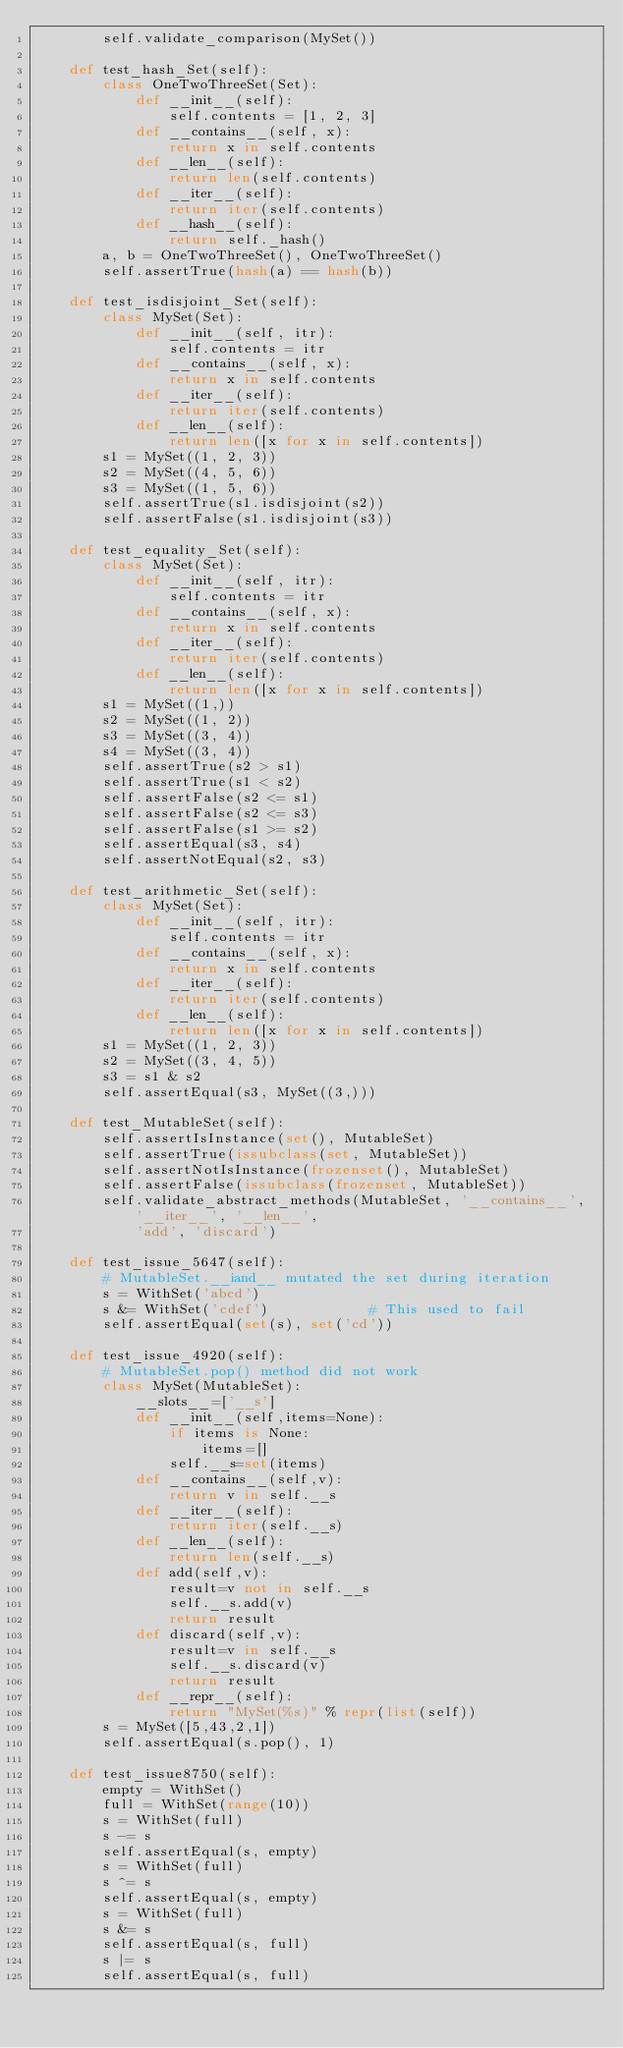<code> <loc_0><loc_0><loc_500><loc_500><_Python_>        self.validate_comparison(MySet())

    def test_hash_Set(self):
        class OneTwoThreeSet(Set):
            def __init__(self):
                self.contents = [1, 2, 3]
            def __contains__(self, x):
                return x in self.contents
            def __len__(self):
                return len(self.contents)
            def __iter__(self):
                return iter(self.contents)
            def __hash__(self):
                return self._hash()
        a, b = OneTwoThreeSet(), OneTwoThreeSet()
        self.assertTrue(hash(a) == hash(b))

    def test_isdisjoint_Set(self):
        class MySet(Set):
            def __init__(self, itr):
                self.contents = itr
            def __contains__(self, x):
                return x in self.contents
            def __iter__(self):
                return iter(self.contents)
            def __len__(self):
                return len([x for x in self.contents])
        s1 = MySet((1, 2, 3))
        s2 = MySet((4, 5, 6))
        s3 = MySet((1, 5, 6))
        self.assertTrue(s1.isdisjoint(s2))
        self.assertFalse(s1.isdisjoint(s3))

    def test_equality_Set(self):
        class MySet(Set):
            def __init__(self, itr):
                self.contents = itr
            def __contains__(self, x):
                return x in self.contents
            def __iter__(self):
                return iter(self.contents)
            def __len__(self):
                return len([x for x in self.contents])
        s1 = MySet((1,))
        s2 = MySet((1, 2))
        s3 = MySet((3, 4))
        s4 = MySet((3, 4))
        self.assertTrue(s2 > s1)
        self.assertTrue(s1 < s2)
        self.assertFalse(s2 <= s1)
        self.assertFalse(s2 <= s3)
        self.assertFalse(s1 >= s2)
        self.assertEqual(s3, s4)
        self.assertNotEqual(s2, s3)

    def test_arithmetic_Set(self):
        class MySet(Set):
            def __init__(self, itr):
                self.contents = itr
            def __contains__(self, x):
                return x in self.contents
            def __iter__(self):
                return iter(self.contents)
            def __len__(self):
                return len([x for x in self.contents])
        s1 = MySet((1, 2, 3))
        s2 = MySet((3, 4, 5))
        s3 = s1 & s2
        self.assertEqual(s3, MySet((3,)))

    def test_MutableSet(self):
        self.assertIsInstance(set(), MutableSet)
        self.assertTrue(issubclass(set, MutableSet))
        self.assertNotIsInstance(frozenset(), MutableSet)
        self.assertFalse(issubclass(frozenset, MutableSet))
        self.validate_abstract_methods(MutableSet, '__contains__', '__iter__', '__len__',
            'add', 'discard')

    def test_issue_5647(self):
        # MutableSet.__iand__ mutated the set during iteration
        s = WithSet('abcd')
        s &= WithSet('cdef')            # This used to fail
        self.assertEqual(set(s), set('cd'))

    def test_issue_4920(self):
        # MutableSet.pop() method did not work
        class MySet(MutableSet):
            __slots__=['__s']
            def __init__(self,items=None):
                if items is None:
                    items=[]
                self.__s=set(items)
            def __contains__(self,v):
                return v in self.__s
            def __iter__(self):
                return iter(self.__s)
            def __len__(self):
                return len(self.__s)
            def add(self,v):
                result=v not in self.__s
                self.__s.add(v)
                return result
            def discard(self,v):
                result=v in self.__s
                self.__s.discard(v)
                return result
            def __repr__(self):
                return "MySet(%s)" % repr(list(self))
        s = MySet([5,43,2,1])
        self.assertEqual(s.pop(), 1)

    def test_issue8750(self):
        empty = WithSet()
        full = WithSet(range(10))
        s = WithSet(full)
        s -= s
        self.assertEqual(s, empty)
        s = WithSet(full)
        s ^= s
        self.assertEqual(s, empty)
        s = WithSet(full)
        s &= s
        self.assertEqual(s, full)
        s |= s
        self.assertEqual(s, full)
</code> 